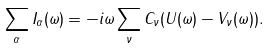<formula> <loc_0><loc_0><loc_500><loc_500>\sum _ { \alpha } I _ { \alpha } ( \omega ) = - i \omega \sum _ { \nu } C _ { \nu } ( U ( \omega ) - V _ { \nu } ( \omega ) ) .</formula> 